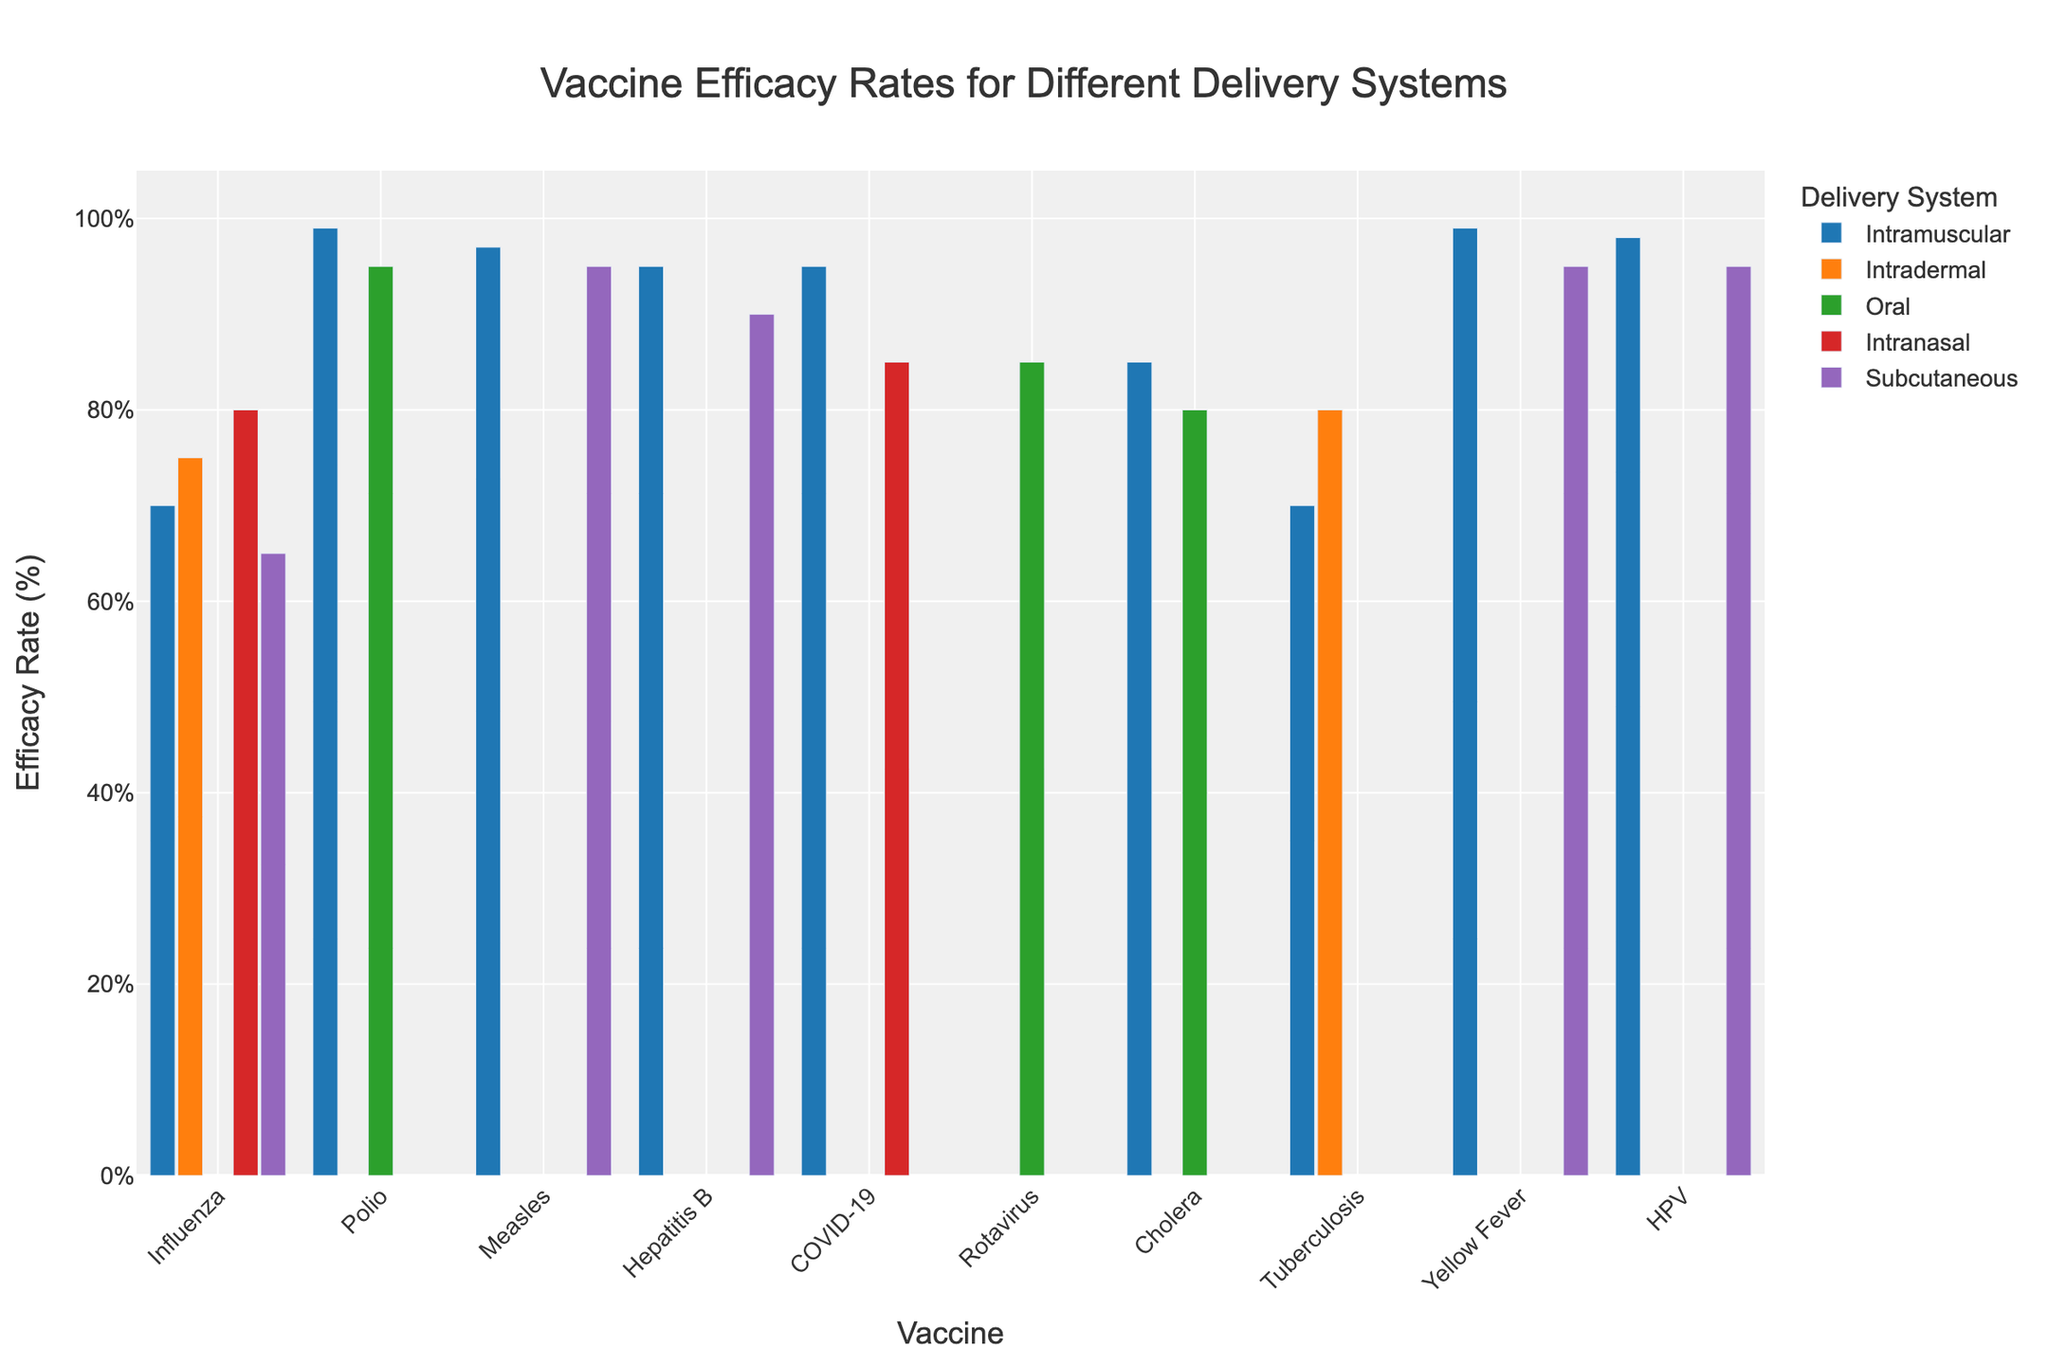Which vaccine has the highest efficacy rate for the intramuscular delivery system? Find the bar with the highest value for the intramuscular delivery system and read its corresponding vaccine name. The highest is 99%, corresponding to the Yellow Fever vaccine.
Answer: Yellow Fever What is the average efficacy rate for the vaccines using the intramuscular delivery system? Add the efficacy rates for all vaccines using the intramuscular delivery system (70 + 99 + 97 + 95 + 95 + 85 + 70 + 99 + 98) and divide by the total number of vaccines (9). (70 + 99 + 97 + 95 + 95 + 85 + 70 + 99 + 98) / 9 = 90
Answer: 90 Which delivery system shows the highest efficacy for the Tuberculosis vaccine? Compare the efficacy rates for the Tuberculosis vaccine across different delivery systems. The highest value is 80%, associated with the intradermal delivery system.
Answer: Intradermal How does the efficacy rate of the Influenza vaccine using the intradermal delivery system compare to the intramuscular delivery system? Subtract the efficacy rate of the intramuscular system (70%) from the intradermal system (75%). The difference is 75 - 70 = 5.
Answer: 5% higher What is the difference in efficacy rates for the Intranasal delivery system between the Influenza and COVID-19 vaccines? Subtract the efficacy rate of the COVID-19 vaccine (85%) from the efficacy rate of the Influenza vaccine (80%). The difference is 85 - 80 = 5.
Answer: 5% Which delivery systems are used for the Polio vaccine, and which one has the highest efficacy rate? Identify all delivery systems used for the Polio vaccine and then find the one with the highest efficacy rate. The Polio vaccine is available for the intramuscular and oral delivery systems, with the highest efficacy of 99% for the intramuscular system.
Answer: Intramuscular Compare the efficacy rates of the Measles vaccine using the subcutaneous delivery system and the intramuscular system. Which one is higher? Observe and compare the efficacy rates (Intramuscular: 97%, Subcutaneous: 95%) and identify which one is higher. The intramuscular system has a higher efficacy rate.
Answer: Intramuscular What is the sum of efficacy rates for the COVID-19 vaccine across all delivery systems? Add the efficacy rates for the COVID-19 vaccine across all available delivery systems (95 intramuscular + 85 intranasal). The sum is 95 + 85 = 180.
Answer: 180 For which delivery system is the efficacy rate available for the most vaccines? Count the number of vaccines for each delivery system and determine which system has the most. The intramuscular system has the most with data for 9 vaccines.
Answer: Intramuscular What is the lowest efficacy rate for any vaccine using the oral delivery system? Identify all efficacy rates for the oral delivery system and then find the lowest value, which is 80% for the Cholera vaccine.
Answer: 80% 